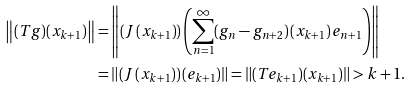<formula> <loc_0><loc_0><loc_500><loc_500>\left \| ( T g ) ( x _ { k + 1 } ) \right \| & = \left \| \left ( J \left ( x _ { k + 1 } \right ) \right ) \left ( \sum _ { n = 1 } ^ { \infty } ( g _ { n } - g _ { n + 2 } ) \left ( x _ { k + 1 } \right ) e _ { n + 1 } \right ) \right \| \\ & = \left \| \left ( J \left ( x _ { k + 1 } \right ) \right ) \left ( e _ { k + 1 } \right ) \right \| = \left \| ( T e _ { k + 1 } ) ( x _ { k + 1 } ) \right \| > k + 1 .</formula> 